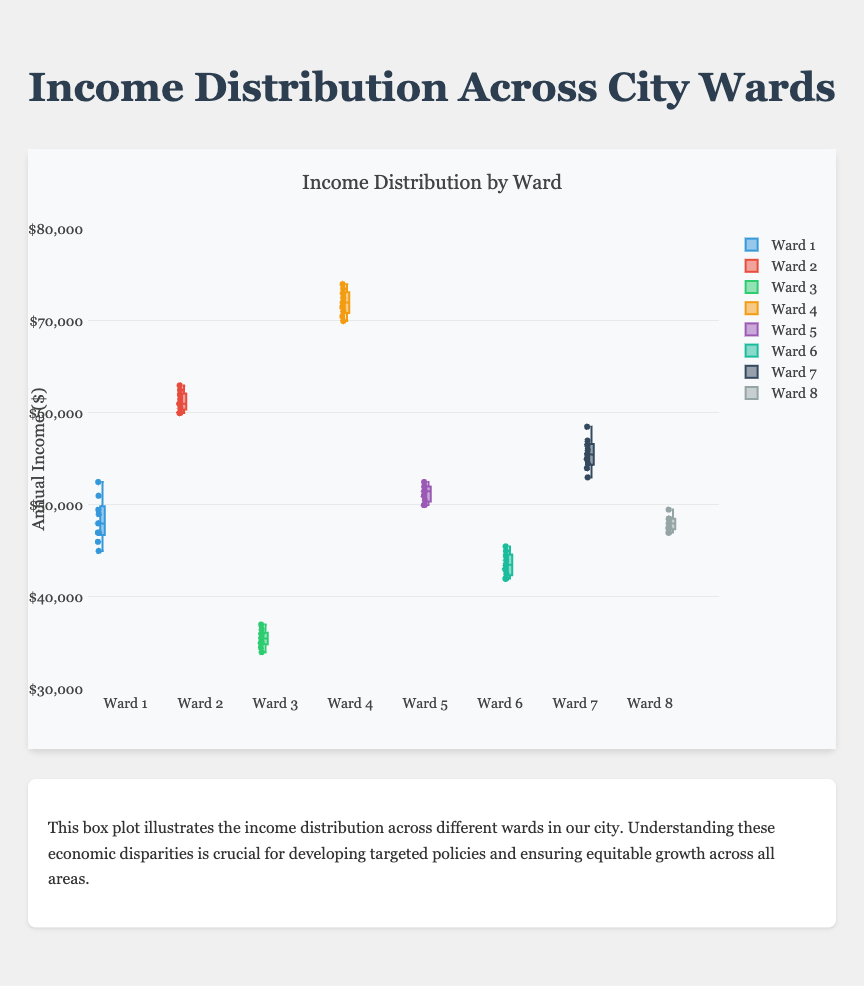Which ward has the highest median annual income? To find the highest median annual income, visually inspect the box plots and identify the ward with the highest centerline. The centerline of Ward 4 is above all others.
Answer: Ward 4 Which ward has the lowest median annual income? To determine the lowest median annual income, look for the box plot with the lowest centerline. The centerline of Ward 3 is the lowest among all wards.
Answer: Ward 3 What is the approximate range of incomes in Ward 2? The range of incomes in Ward 2 can be estimated by subtracting the minimum value (bottom whisker) from the maximum value (top whisker) in the box plot.
Answer: 60000 to 63000 Which wards have a median annual income greater than $60,000? Identify the centerlines of the box plots that are above the $60,000 mark. Wards 2, 4, and 7 have centerlines above $60,000.
Answer: Wards 2, 4, and 7 What is the interquartile range (IQR) for Ward 6? The IQR is the difference between the upper quartile and the lower quartile. For Ward 6, locate the top and bottom edges of the box and subtract the lower quartile from the upper quartile.
Answer: 45000 - 42500 = 2500 Which ward shows the greatest variation in annual income? Look for the ward with the longest distance between the bottom and top whiskers in the box plot. Ward 4 has the greatest variation as its whiskers span the widest range.
Answer: Ward 4 Between Ward 1 and Ward 5, which has a higher third quartile income? Compare the top edges of the boxes for Ward 1 and Ward 5. Ward 5's top edge (third quartile) is higher than Ward 1's.
Answer: Ward 5 Do any wards share the exact same minimum income level? Compare the bottom whiskers of all the wards to see if any align perfectly. Wards 1 and 5 both have a bottom whisker at $45000.
Answer: Wards 1 and 5 Which ward has the narrowest income distribution around the median? Look for the ward whose box (IQR) is the shortest in height. Ward 8 has the narrowest interquartile range, indicating the least spread around the median.
Answer: Ward 8 